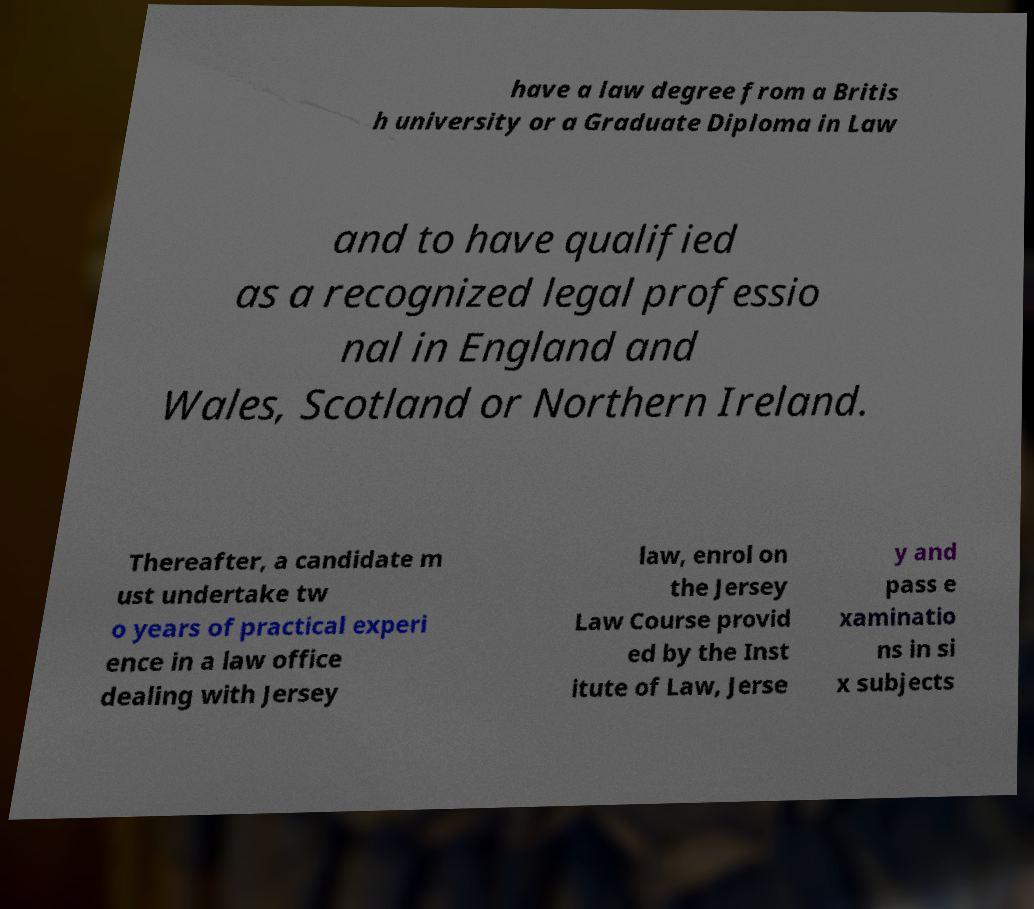Could you assist in decoding the text presented in this image and type it out clearly? have a law degree from a Britis h university or a Graduate Diploma in Law and to have qualified as a recognized legal professio nal in England and Wales, Scotland or Northern Ireland. Thereafter, a candidate m ust undertake tw o years of practical experi ence in a law office dealing with Jersey law, enrol on the Jersey Law Course provid ed by the Inst itute of Law, Jerse y and pass e xaminatio ns in si x subjects 